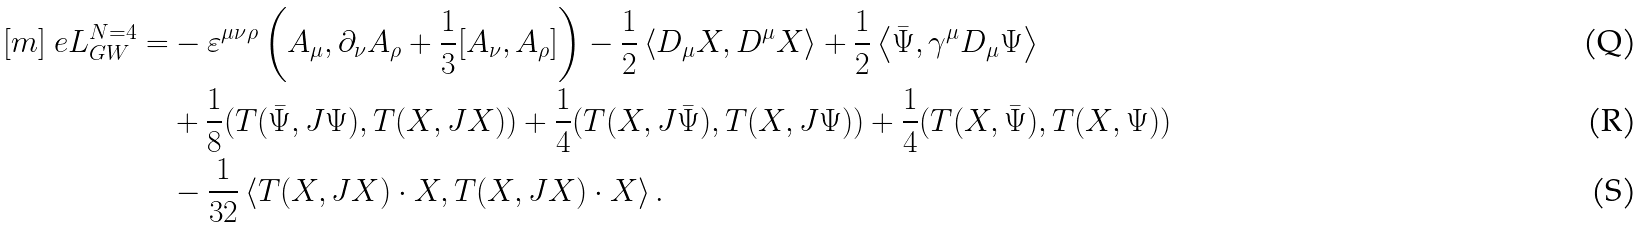<formula> <loc_0><loc_0><loc_500><loc_500>[ m ] \ e L _ { G W } ^ { N { = } 4 } = & - \varepsilon ^ { \mu \nu \rho } \left ( A _ { \mu } , \partial _ { \nu } A _ { \rho } + \frac { 1 } { 3 } [ A _ { \nu } , A _ { \rho } ] \right ) - \frac { 1 } { 2 } \left < D _ { \mu } X , D ^ { \mu } X \right > + \frac { 1 } { 2 } \left < { \bar { \Psi } } , \gamma ^ { \mu } D _ { \mu } \Psi \right > \\ & + \frac { 1 } { 8 } ( T ( { \bar { \Psi } } , J \Psi ) , T ( X , J X ) ) + \frac { 1 } { 4 } ( T ( X , J { \bar { \Psi } } ) , T ( X , J \Psi ) ) + \frac { 1 } { 4 } ( T ( X , { \bar { \Psi } } ) , T ( X , \Psi ) ) \\ & - \frac { 1 } { 3 2 } \left < T ( X , J X ) \cdot X , T ( X , J X ) \cdot X \right > .</formula> 